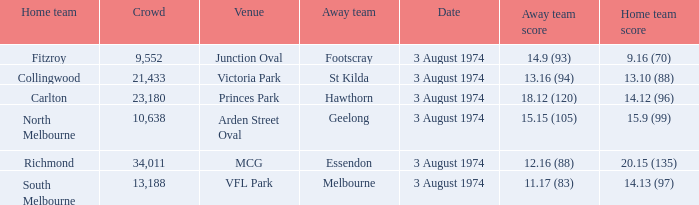Which Venue has a Home team score of 9.16 (70)? Junction Oval. 